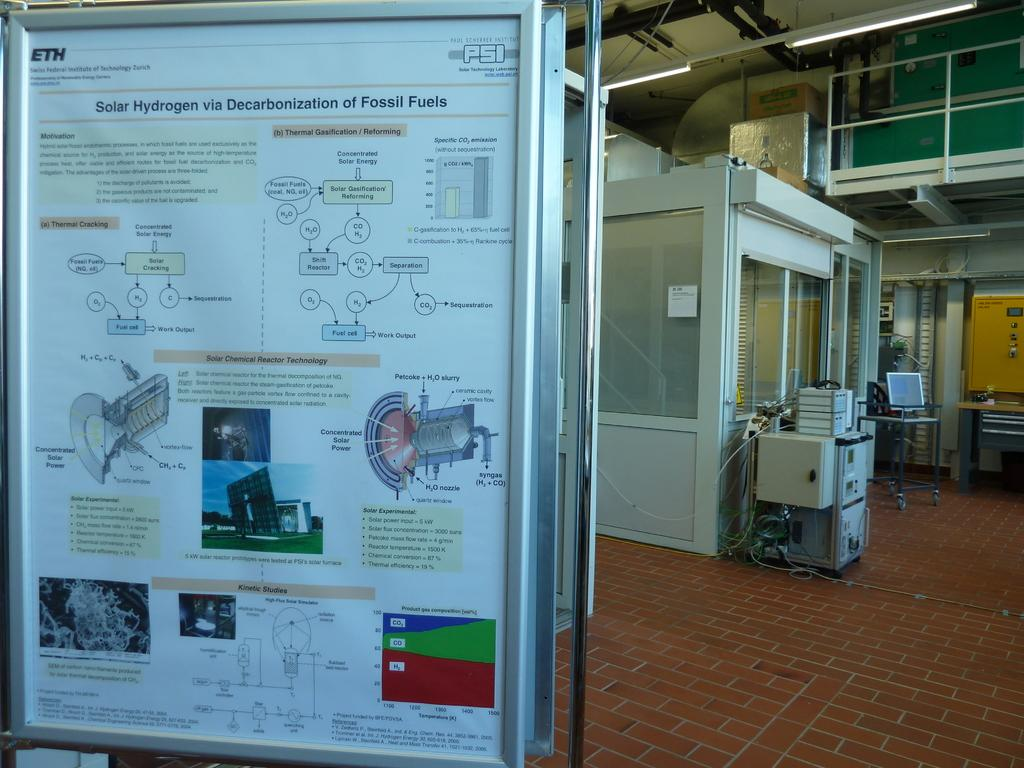What is featured in the image? There is a poster in the image. What can be found on the poster? The poster contains pictures and text. What can be seen in the background of the image? There are cabins, a machine, light, and other objects in the background of the image. What type of lumber is being used to create the basket in the image? There is no basket or lumber present in the image. What health benefits are mentioned in the image? The image does not mention any health benefits, as it primarily features a poster with pictures and text. 